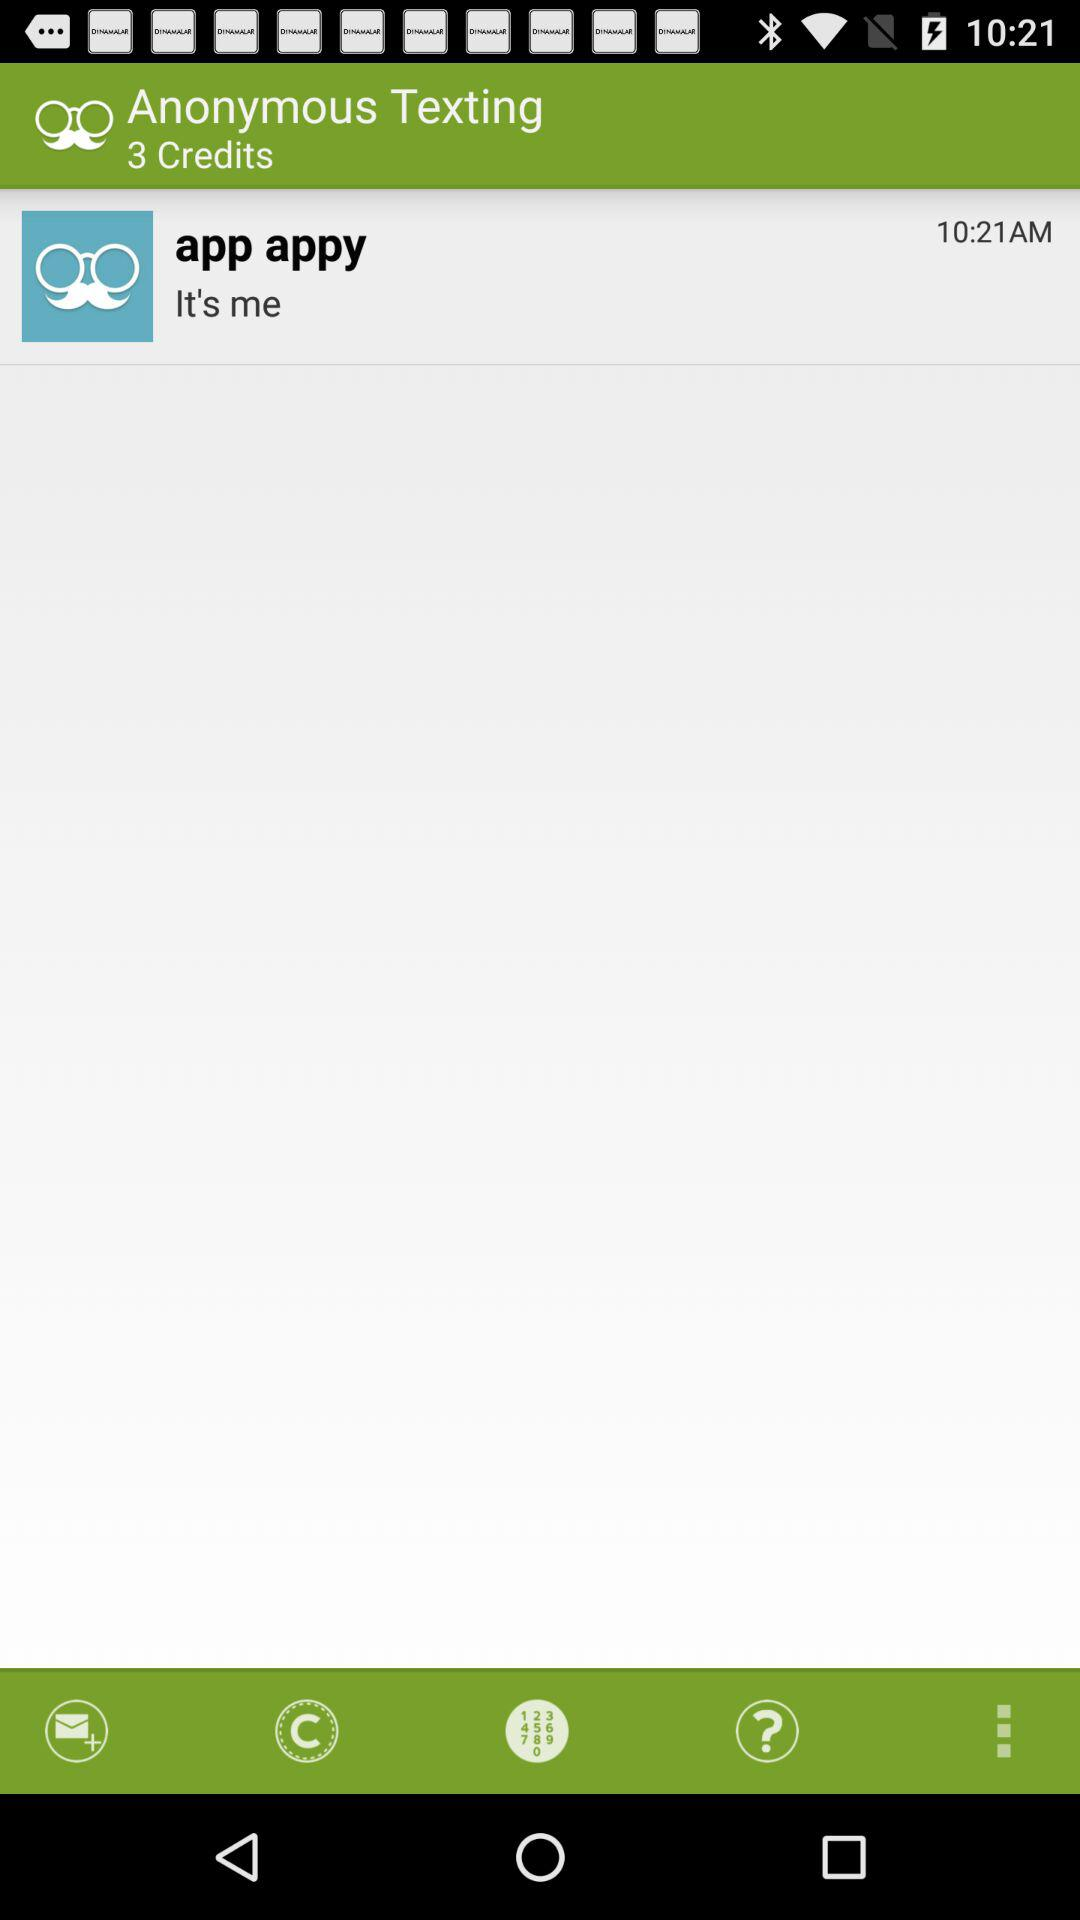How many credits are there?
Answer the question using a single word or phrase. 3 